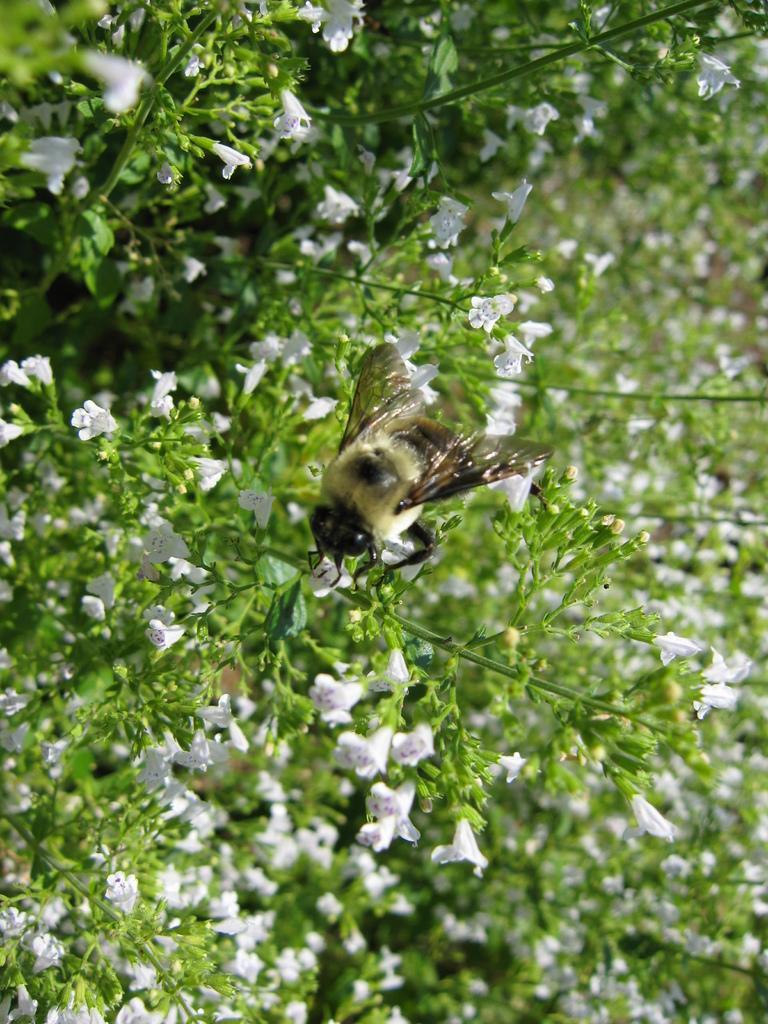Can you describe this image briefly? In this image, we can see a bee on the plant, we can see some flowers on the plants. 